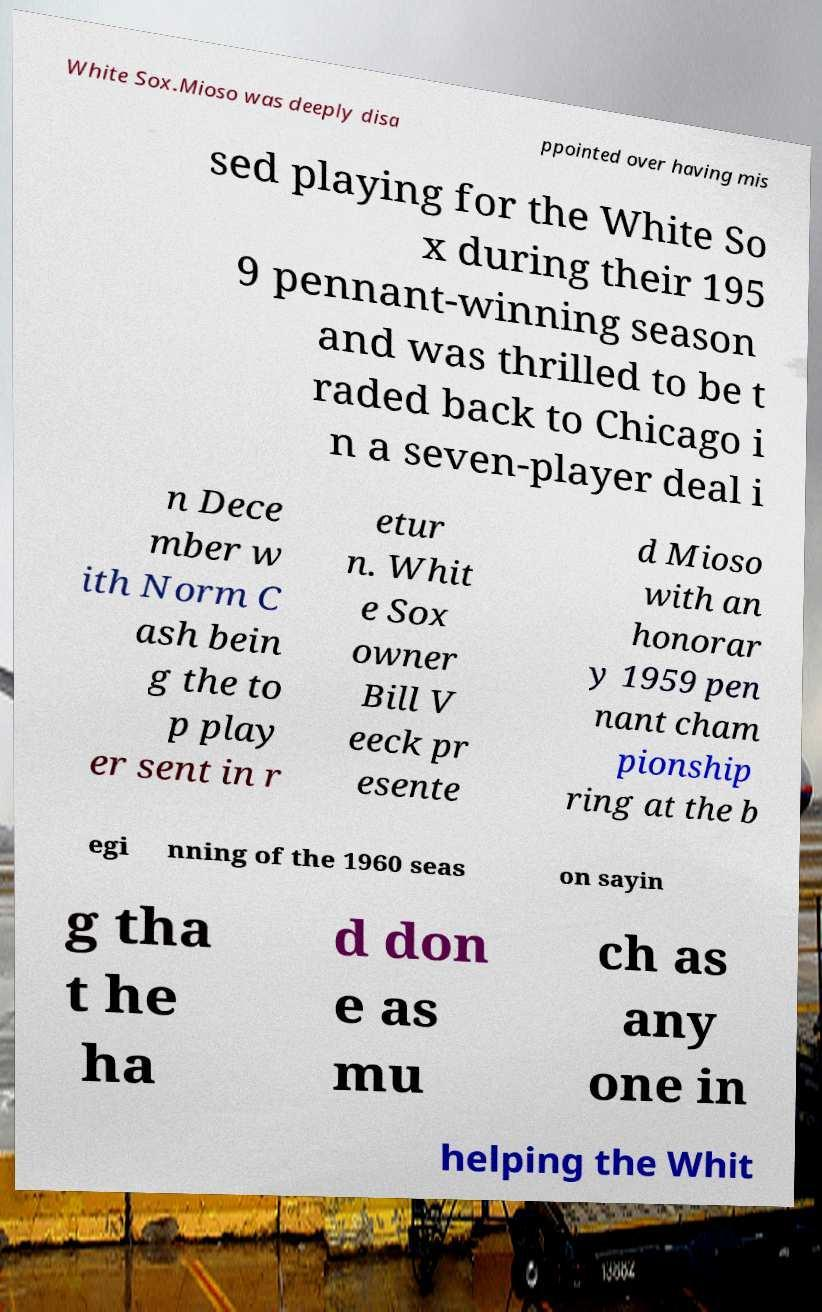What messages or text are displayed in this image? I need them in a readable, typed format. White Sox.Mioso was deeply disa ppointed over having mis sed playing for the White So x during their 195 9 pennant-winning season and was thrilled to be t raded back to Chicago i n a seven-player deal i n Dece mber w ith Norm C ash bein g the to p play er sent in r etur n. Whit e Sox owner Bill V eeck pr esente d Mioso with an honorar y 1959 pen nant cham pionship ring at the b egi nning of the 1960 seas on sayin g tha t he ha d don e as mu ch as any one in helping the Whit 